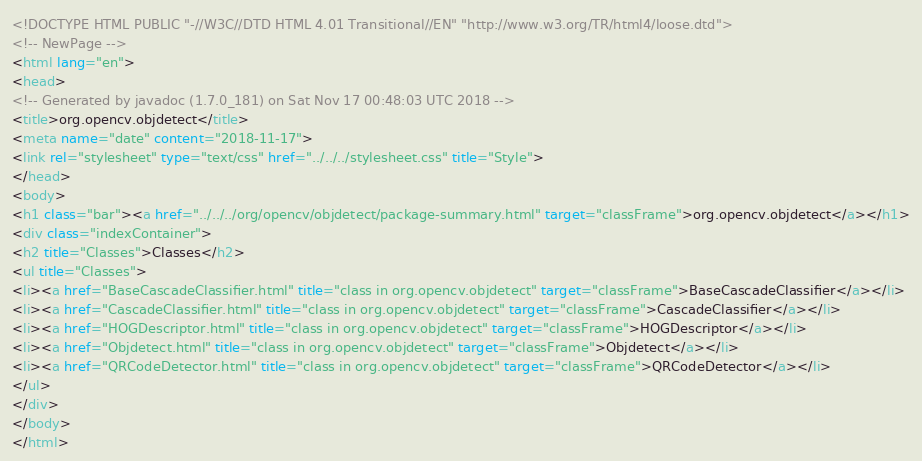<code> <loc_0><loc_0><loc_500><loc_500><_HTML_><!DOCTYPE HTML PUBLIC "-//W3C//DTD HTML 4.01 Transitional//EN" "http://www.w3.org/TR/html4/loose.dtd">
<!-- NewPage -->
<html lang="en">
<head>
<!-- Generated by javadoc (1.7.0_181) on Sat Nov 17 00:48:03 UTC 2018 -->
<title>org.opencv.objdetect</title>
<meta name="date" content="2018-11-17">
<link rel="stylesheet" type="text/css" href="../../../stylesheet.css" title="Style">
</head>
<body>
<h1 class="bar"><a href="../../../org/opencv/objdetect/package-summary.html" target="classFrame">org.opencv.objdetect</a></h1>
<div class="indexContainer">
<h2 title="Classes">Classes</h2>
<ul title="Classes">
<li><a href="BaseCascadeClassifier.html" title="class in org.opencv.objdetect" target="classFrame">BaseCascadeClassifier</a></li>
<li><a href="CascadeClassifier.html" title="class in org.opencv.objdetect" target="classFrame">CascadeClassifier</a></li>
<li><a href="HOGDescriptor.html" title="class in org.opencv.objdetect" target="classFrame">HOGDescriptor</a></li>
<li><a href="Objdetect.html" title="class in org.opencv.objdetect" target="classFrame">Objdetect</a></li>
<li><a href="QRCodeDetector.html" title="class in org.opencv.objdetect" target="classFrame">QRCodeDetector</a></li>
</ul>
</div>
</body>
</html>
</code> 